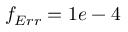Convert formula to latex. <formula><loc_0><loc_0><loc_500><loc_500>f _ { E r r } = 1 e - 4</formula> 